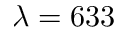<formula> <loc_0><loc_0><loc_500><loc_500>\lambda = 6 3 3</formula> 